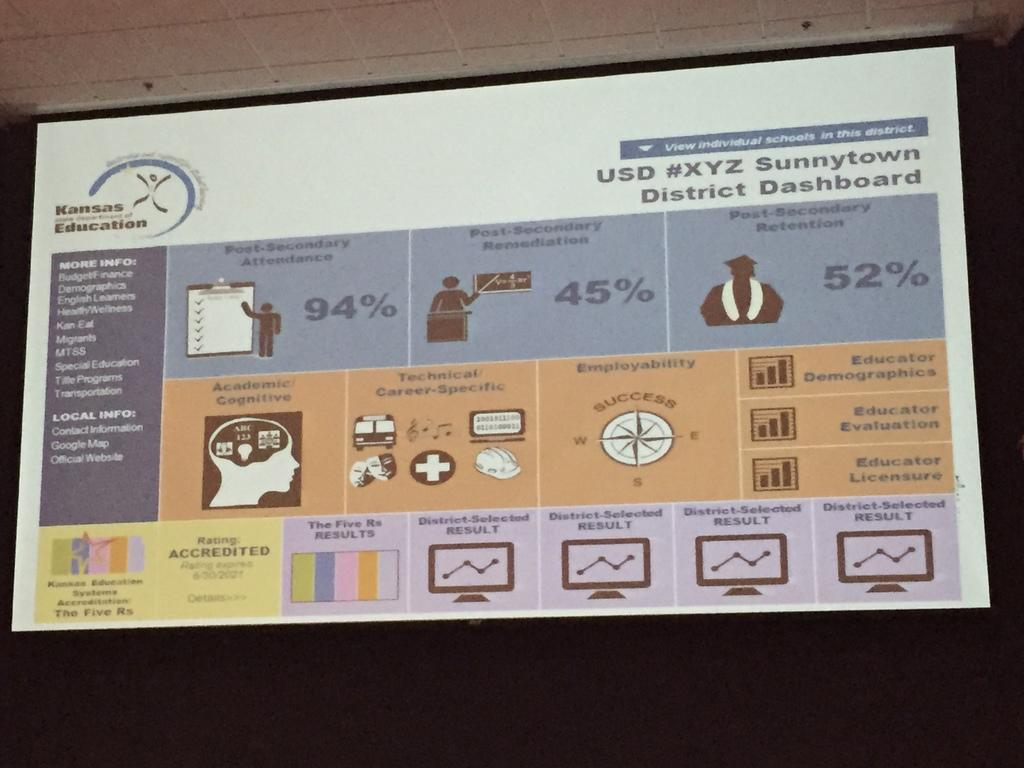<image>
Offer a succinct explanation of the picture presented. A display of information for Kansas Education's Sunnytown District Dashboard. 